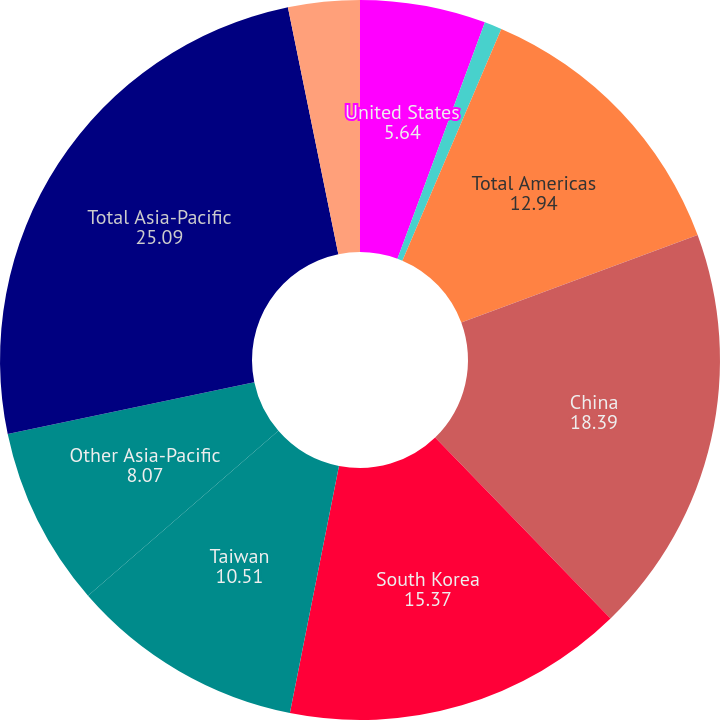Convert chart to OTSL. <chart><loc_0><loc_0><loc_500><loc_500><pie_chart><fcel>United States<fcel>Other Americas<fcel>Total Americas<fcel>China<fcel>South Korea<fcel>Taiwan<fcel>Other Asia-Pacific<fcel>Total Asia-Pacific<fcel>Europe Middle East and Africa<nl><fcel>5.64%<fcel>0.78%<fcel>12.94%<fcel>18.39%<fcel>15.37%<fcel>10.51%<fcel>8.07%<fcel>25.09%<fcel>3.21%<nl></chart> 